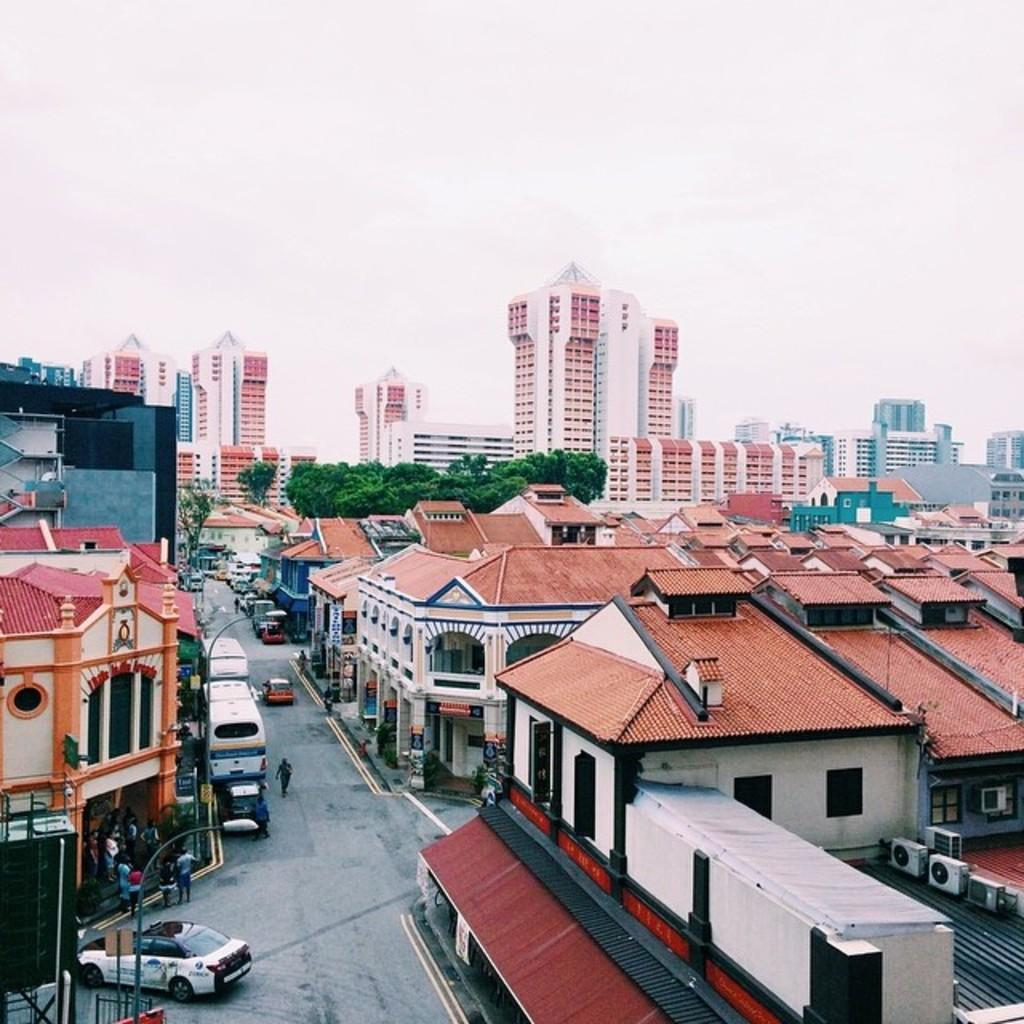What type of view is shown in the image? The image is an aerial view of a city. What structures can be seen in the image? There are buildings in the image. What vehicles are present in the image? There are cars and buses in the image. What type of transportation infrastructure is visible in the image? There are roads in the image. What type of vegetation can be seen in the image? There are trees in the image. Can people be seen in the image? Yes, there are people in the image. What objects are present on the right side of the image? There are air conditioners on the right side of the image. What is the weather like in the image? The sky is cloudy in the image. What type of doll is being used to make a selection on the calculator in the image? There is no doll or calculator present in the image. 